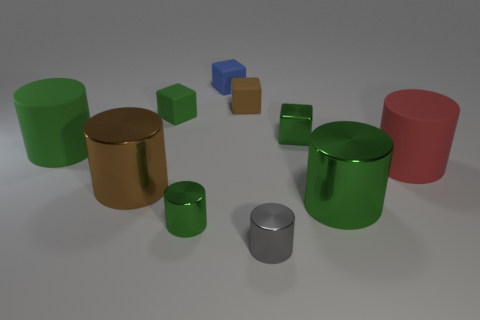How many green cylinders must be subtracted to get 1 green cylinders? 2 Subtract all cyan spheres. How many green cylinders are left? 3 Subtract 3 cylinders. How many cylinders are left? 3 Subtract all brown cylinders. How many cylinders are left? 5 Subtract all gray cylinders. How many cylinders are left? 5 Subtract all gray cylinders. Subtract all cyan cubes. How many cylinders are left? 5 Subtract all blocks. How many objects are left? 6 Add 3 large green things. How many large green things exist? 5 Subtract 0 cyan cubes. How many objects are left? 10 Subtract all gray cylinders. Subtract all tiny green blocks. How many objects are left? 7 